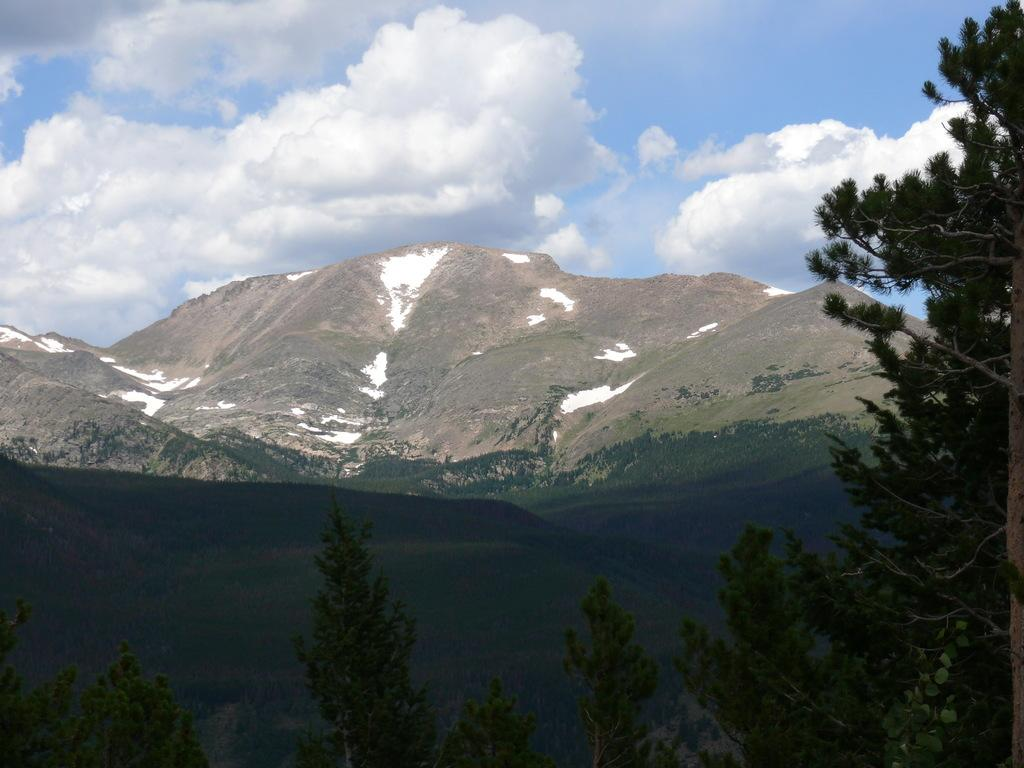What type of vegetation can be seen in the image? There are trees in the image. What is the color of the trees? The trees are green in color. What can be seen in the background of the image? There are mountains and the sky visible in the background of the image. What is the condition of the mountains? The mountains have snow on them. How does the eye of the tree affect the acoustics in the image? There are no eyes present in the image, as trees do not have eyes. Additionally, the concept of acoustics is not relevant to this image, as it does not depict a sound-related scenario. 